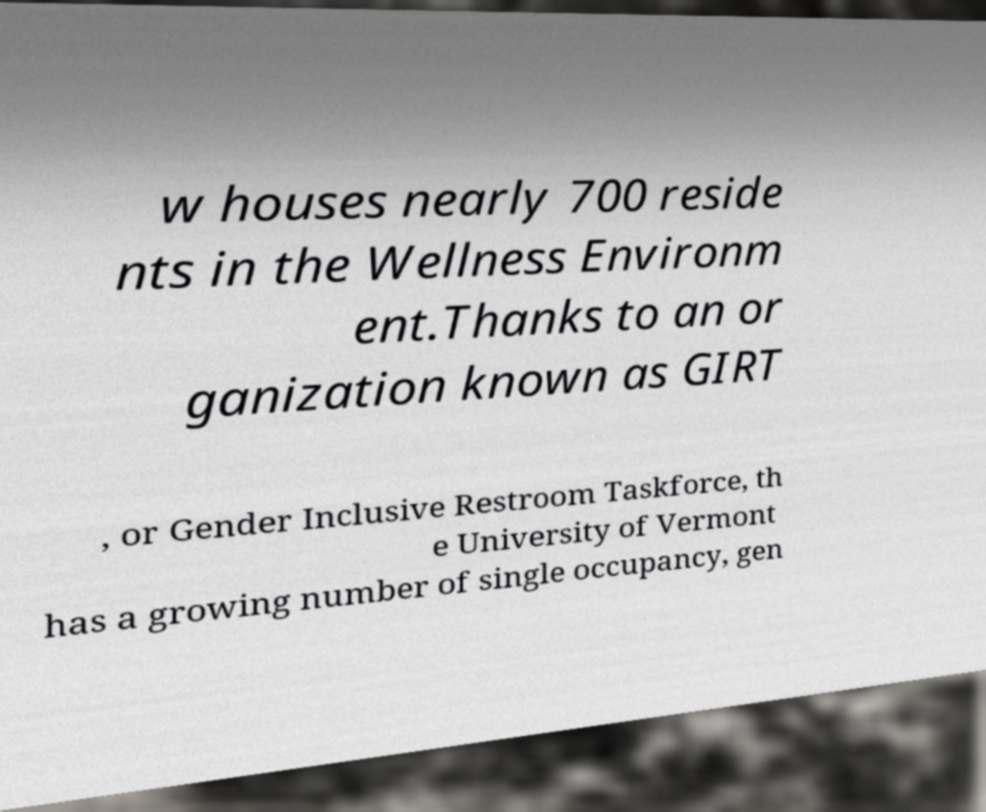Could you assist in decoding the text presented in this image and type it out clearly? w houses nearly 700 reside nts in the Wellness Environm ent.Thanks to an or ganization known as GIRT , or Gender Inclusive Restroom Taskforce, th e University of Vermont has a growing number of single occupancy, gen 